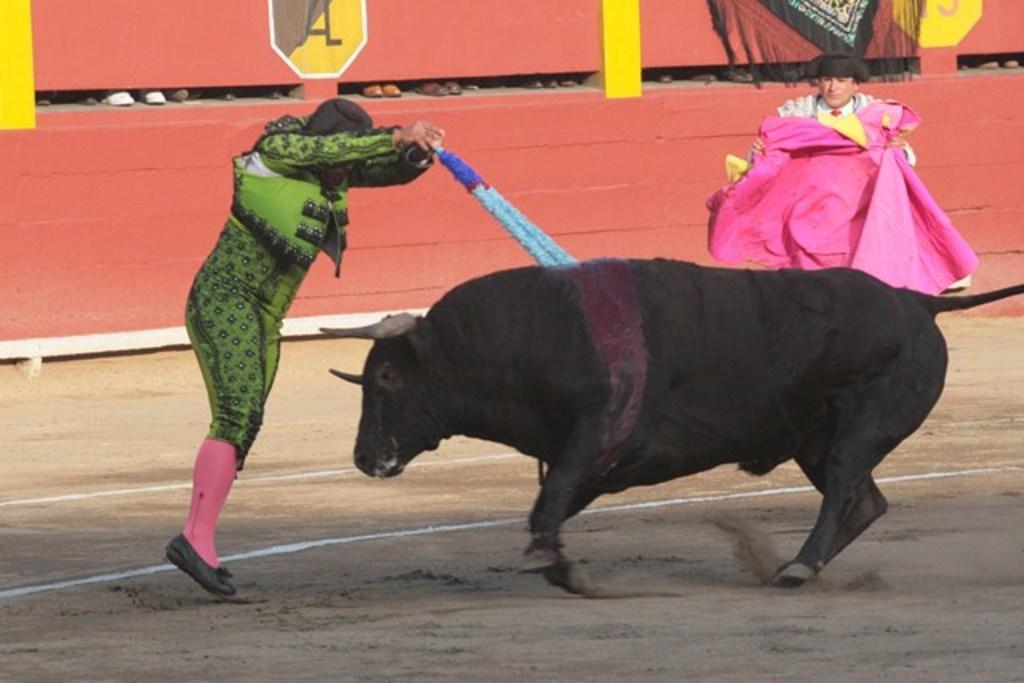Describe this image in one or two sentences. This image is clicked outside. There are two persons in this image. There is an animal in the middle. It is in black color. A person is pushing that animal with some stick. 